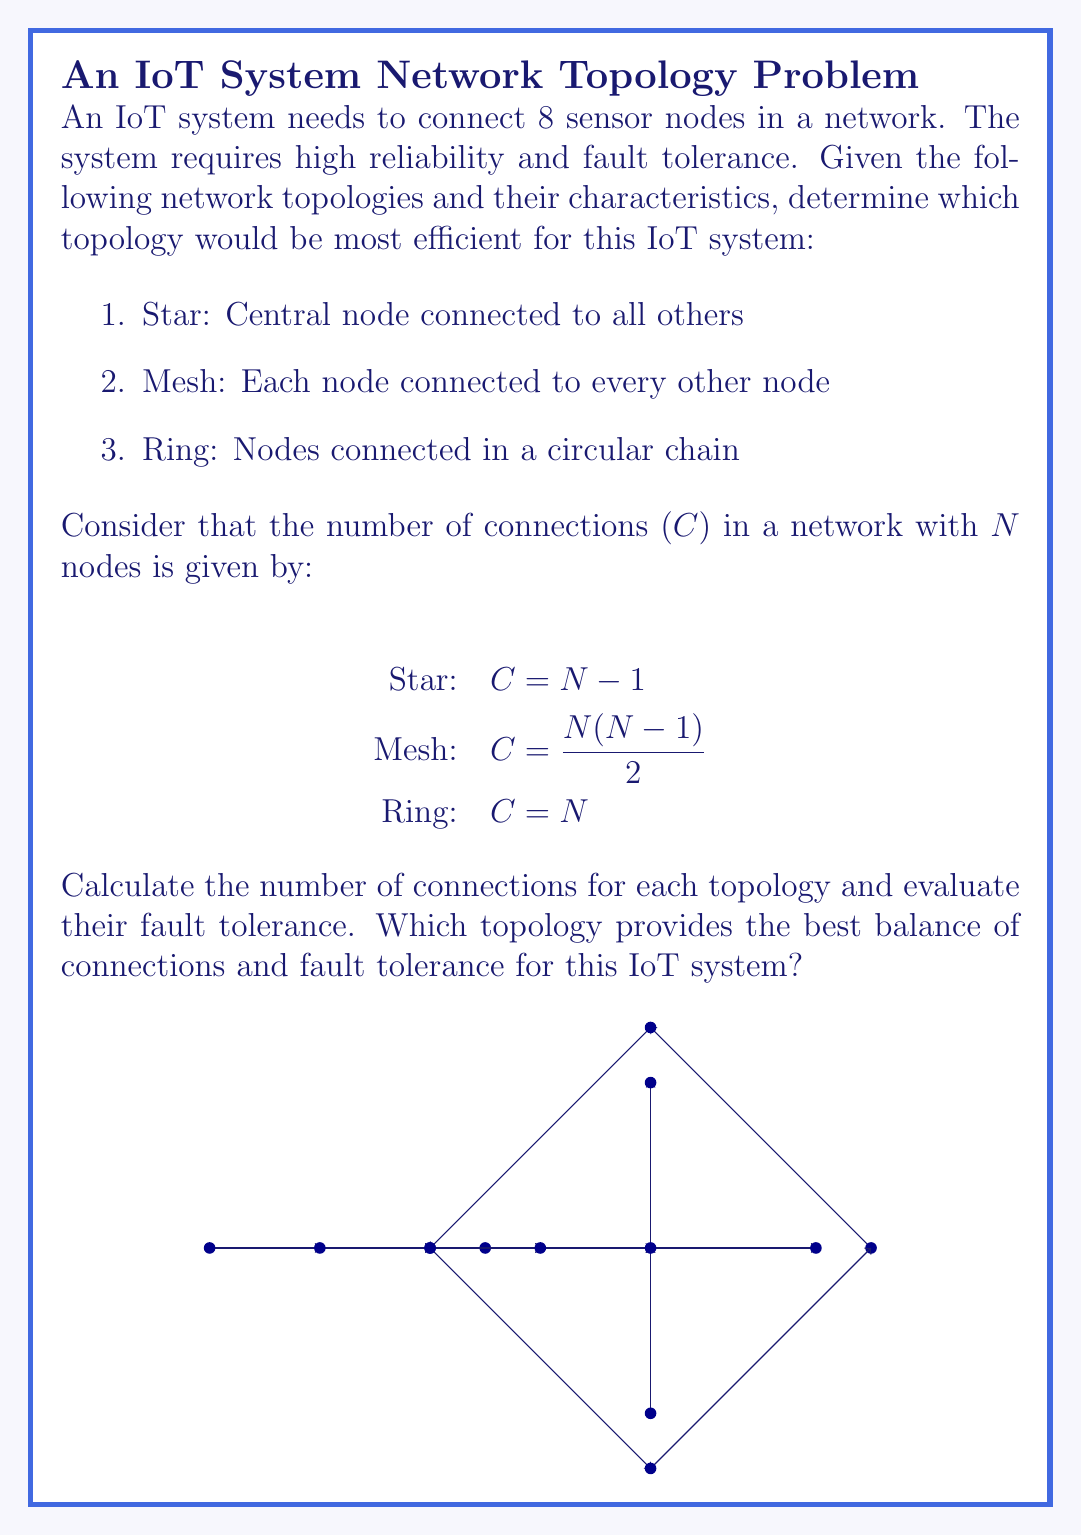Give your solution to this math problem. To determine the most efficient network topology for this IoT system, we need to calculate the number of connections for each topology and evaluate their fault tolerance:

1. Star Topology:
   $C = N - 1 = 8 - 1 = 7$ connections
   - Pros: Simple structure, easy to add/remove nodes
   - Cons: Single point of failure (central node)

2. Mesh Topology:
   $C = \frac{N(N-1)}{2} = \frac{8(8-1)}{2} = \frac{8 \times 7}{2} = 28$ connections
   - Pros: Highest fault tolerance, multiple paths between nodes
   - Cons: Complex, requires more resources

3. Ring Topology:
   $C = N = 8$ connections
   - Pros: Moderate fault tolerance, no central node
   - Cons: Failure of two adjacent nodes can disrupt the entire network

Evaluation:
1. The star topology has the fewest connections but is vulnerable to central node failure.
2. The mesh topology has the highest number of connections and best fault tolerance but is complex.
3. The ring topology offers a balance between connections and fault tolerance.

For an IoT system requiring high reliability and fault tolerance, the mesh topology would be the most efficient. Despite having the most connections, it provides:
1. Multiple paths for data transmission, ensuring continued operation if some nodes fail.
2. No single point of failure, unlike the star topology.
3. Better overall network performance and lower latency compared to the ring topology.

The additional connections in the mesh topology contribute to its superior fault tolerance and reliability, which are crucial for the specified IoT system requirements.
Answer: Mesh topology 